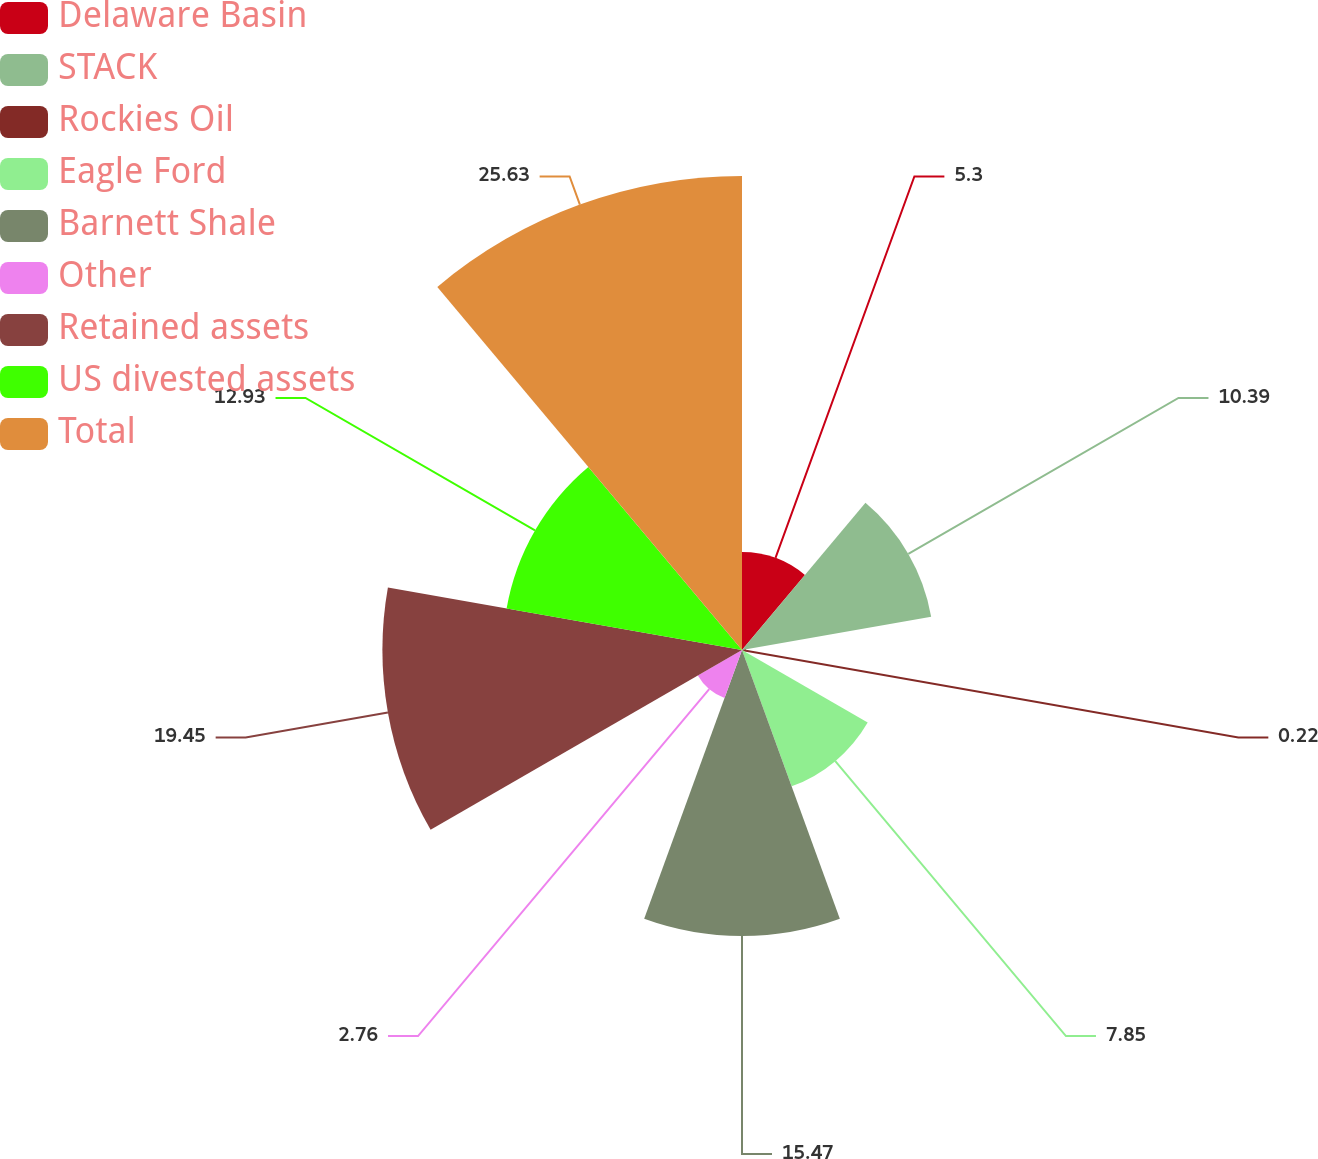Convert chart. <chart><loc_0><loc_0><loc_500><loc_500><pie_chart><fcel>Delaware Basin<fcel>STACK<fcel>Rockies Oil<fcel>Eagle Ford<fcel>Barnett Shale<fcel>Other<fcel>Retained assets<fcel>US divested assets<fcel>Total<nl><fcel>5.3%<fcel>10.39%<fcel>0.22%<fcel>7.85%<fcel>15.47%<fcel>2.76%<fcel>19.45%<fcel>12.93%<fcel>25.64%<nl></chart> 